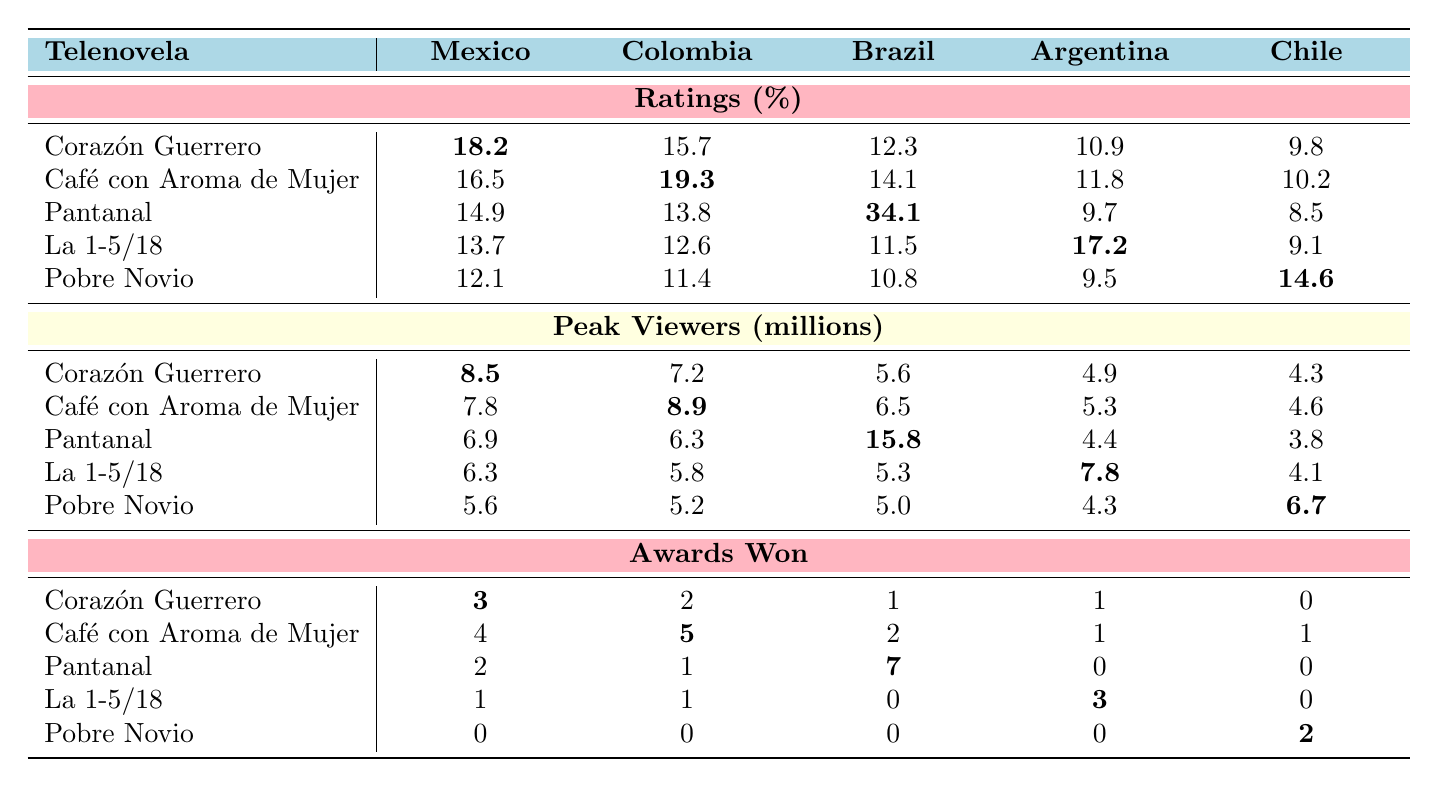What is the highest rating achieved by any telenovela in Mexico? By looking at the ratings for each telenovela listed under Mexico, "Corazón Guerrero" has the highest rating of 18.2%.
Answer: 18.2% Which telenovela received the most awards in Brazil? Reviewing the awards won column for Brazil, "Pantanal" received the most awards with a total of 7.
Answer: Pantanal What is the average peak viewers for "Café con Aroma de Mujer" across all listed countries? The peak viewers for "Café con Aroma de Mujer" are 7.8 (Mexico), 8.9 (Colombia), 6.5 (Brazil), 5.3 (Argentina), and 4.6 (Chile). Summing these gives 33.1, and dividing by 5 gives an average of 6.62.
Answer: 6.62 million Did "Pobre Novio" win any awards in Argentina? Checking the awards won for "Pobre Novio" in Argentina, the value is 0, indicating no awards were won in that country.
Answer: No Which country had the highest rating for the telenovela "Pantanal"? The ratings for "Pantanal" in different countries show that Brazil has the highest rating at 34.1%.
Answer: Brazil What is the difference in peak viewers between "Corazón Guerrero" in Mexico and "La 1-5/18" in Argentina? "Corazón Guerrero" has peak viewers of 8.5 million in Mexico and "La 1-5/18" has 7.8 million in Argentina. The difference is 8.5 - 7.8 = 0.7 million.
Answer: 0.7 million Which telenovela had the lowest audience ratings in Chile? Comparing the ratings in Chile, "Corazón Guerrero", "Café con Aroma de Mujer", "Pantanal", "La 1-5/18", and "Pobre Novio", the lowest rating is from "Pantanal" with 8.5%.
Answer: Pantanal What is the total award count for "Café con Aroma de Mujer" across all countries? Adding the awards for "Café con Aroma de Mujer" gives 4 (Mexico) + 5 (Colombia) + 2 (Brazil) + 1 (Argentina) + 1 (Chile) = 13 awards in total.
Answer: 13 awards In which country did "La 1-5/18" achieve its highest rating, and what was that rating? Analyzing the ratings for "La 1-5/18" across countries, Argentina shows the highest rating of 17.2%.
Answer: Argentina, 17.2% Is "Pantanal" the only telenovela to win awards in all countries noted? Reviewing the awards won for "Pantanal", it won in Brazil, Mexico, Colombia, Argentina, but not in Chile. Therefore, it is not the only telenovela winning awards in all countries.
Answer: No 